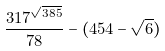Convert formula to latex. <formula><loc_0><loc_0><loc_500><loc_500>\frac { 3 1 7 ^ { \sqrt { 3 8 5 } } } { 7 8 } - ( 4 5 4 - \sqrt { 6 } )</formula> 